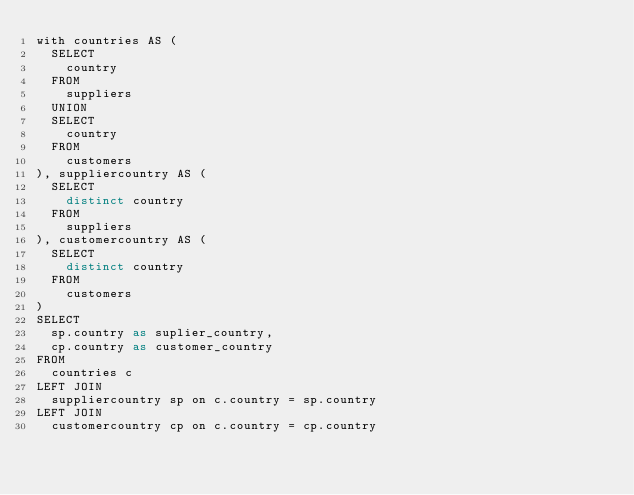<code> <loc_0><loc_0><loc_500><loc_500><_SQL_>with countries AS (
  SELECT
    country
  FROM
    suppliers
  UNION
  SELECT
    country
  FROM
    customers
), suppliercountry AS (
  SELECT
    distinct country
  FROM
    suppliers
), customercountry AS (
  SELECT
    distinct country
  FROM
    customers
)
SELECT
  sp.country as suplier_country,
  cp.country as customer_country
FROM
  countries c
LEFT JOIN
  suppliercountry sp on c.country = sp.country
LEFT JOIN
  customercountry cp on c.country = cp.country
</code> 